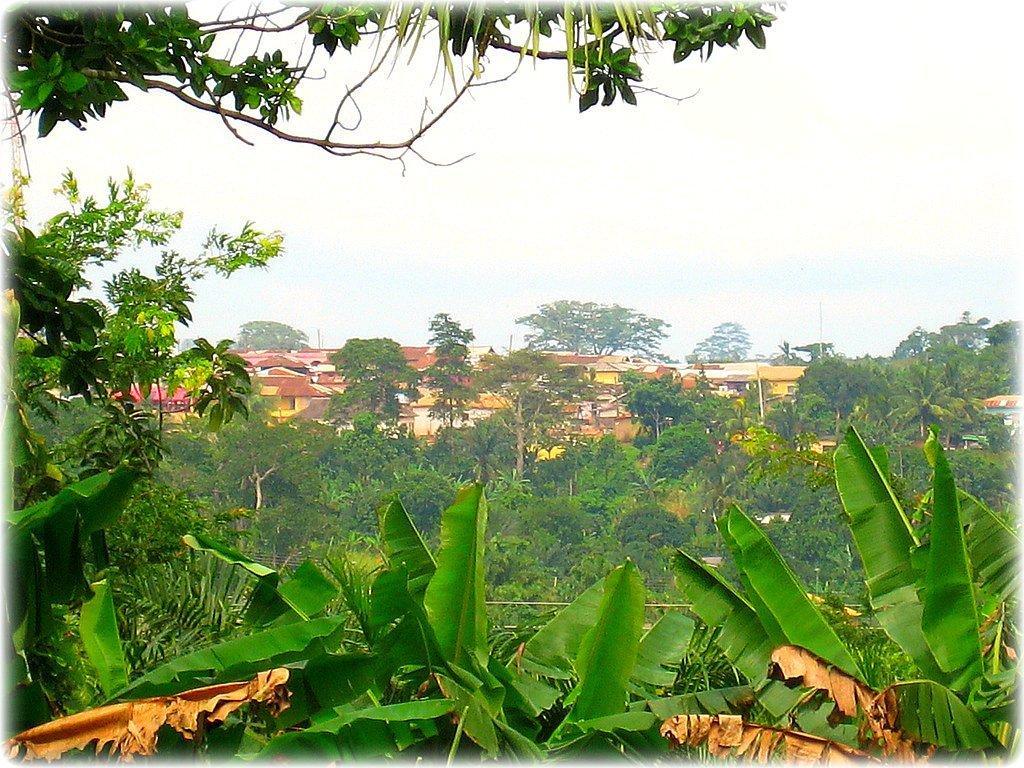In one or two sentences, can you explain what this image depicts? As we can see in the image there are trees and houses in the background. On the top there is sky. 